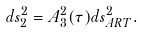<formula> <loc_0><loc_0><loc_500><loc_500>d s _ { 2 } ^ { 2 } = A _ { 3 } ^ { 2 } ( \tau ) d s _ { A R T } ^ { 2 } .</formula> 